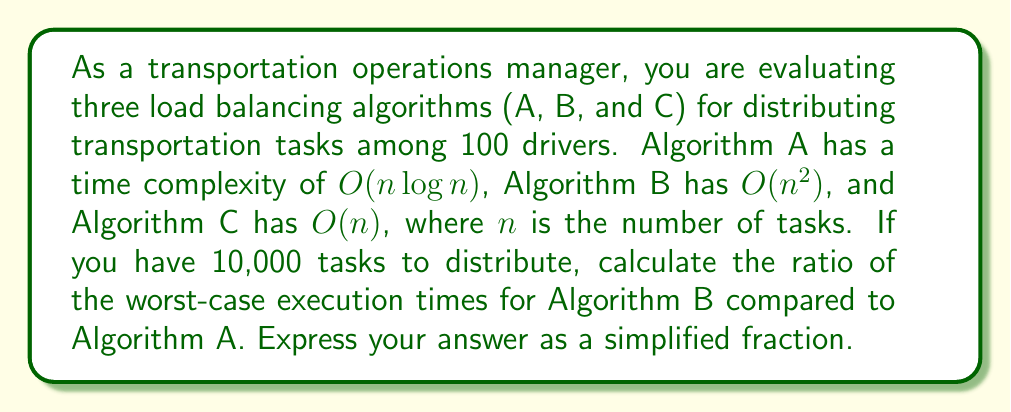Provide a solution to this math problem. To solve this problem, we need to follow these steps:

1) First, let's recall the time complexities:
   Algorithm A: $O(n \log n)$
   Algorithm B: $O(n^2)$
   Algorithm C: $O(n)$

2) We're asked to compare A and B for $n = 10,000$ tasks.

3) For Algorithm A:
   Time $\propto n \log n = 10,000 \log 10,000 = 10,000 \times 4 = 40,000$
   (We use 4 as an approximation for $\log 10,000$)

4) For Algorithm B:
   Time $\propto n^2 = 10,000^2 = 100,000,000$

5) The ratio of B to A is:
   $$\frac{\text{Time for B}}{\text{Time for A}} = \frac{100,000,000}{40,000} = 2,500$$

Therefore, in the worst case, Algorithm B would take 2,500 times longer than Algorithm A for 10,000 tasks.
Answer: 2,500 : 1 